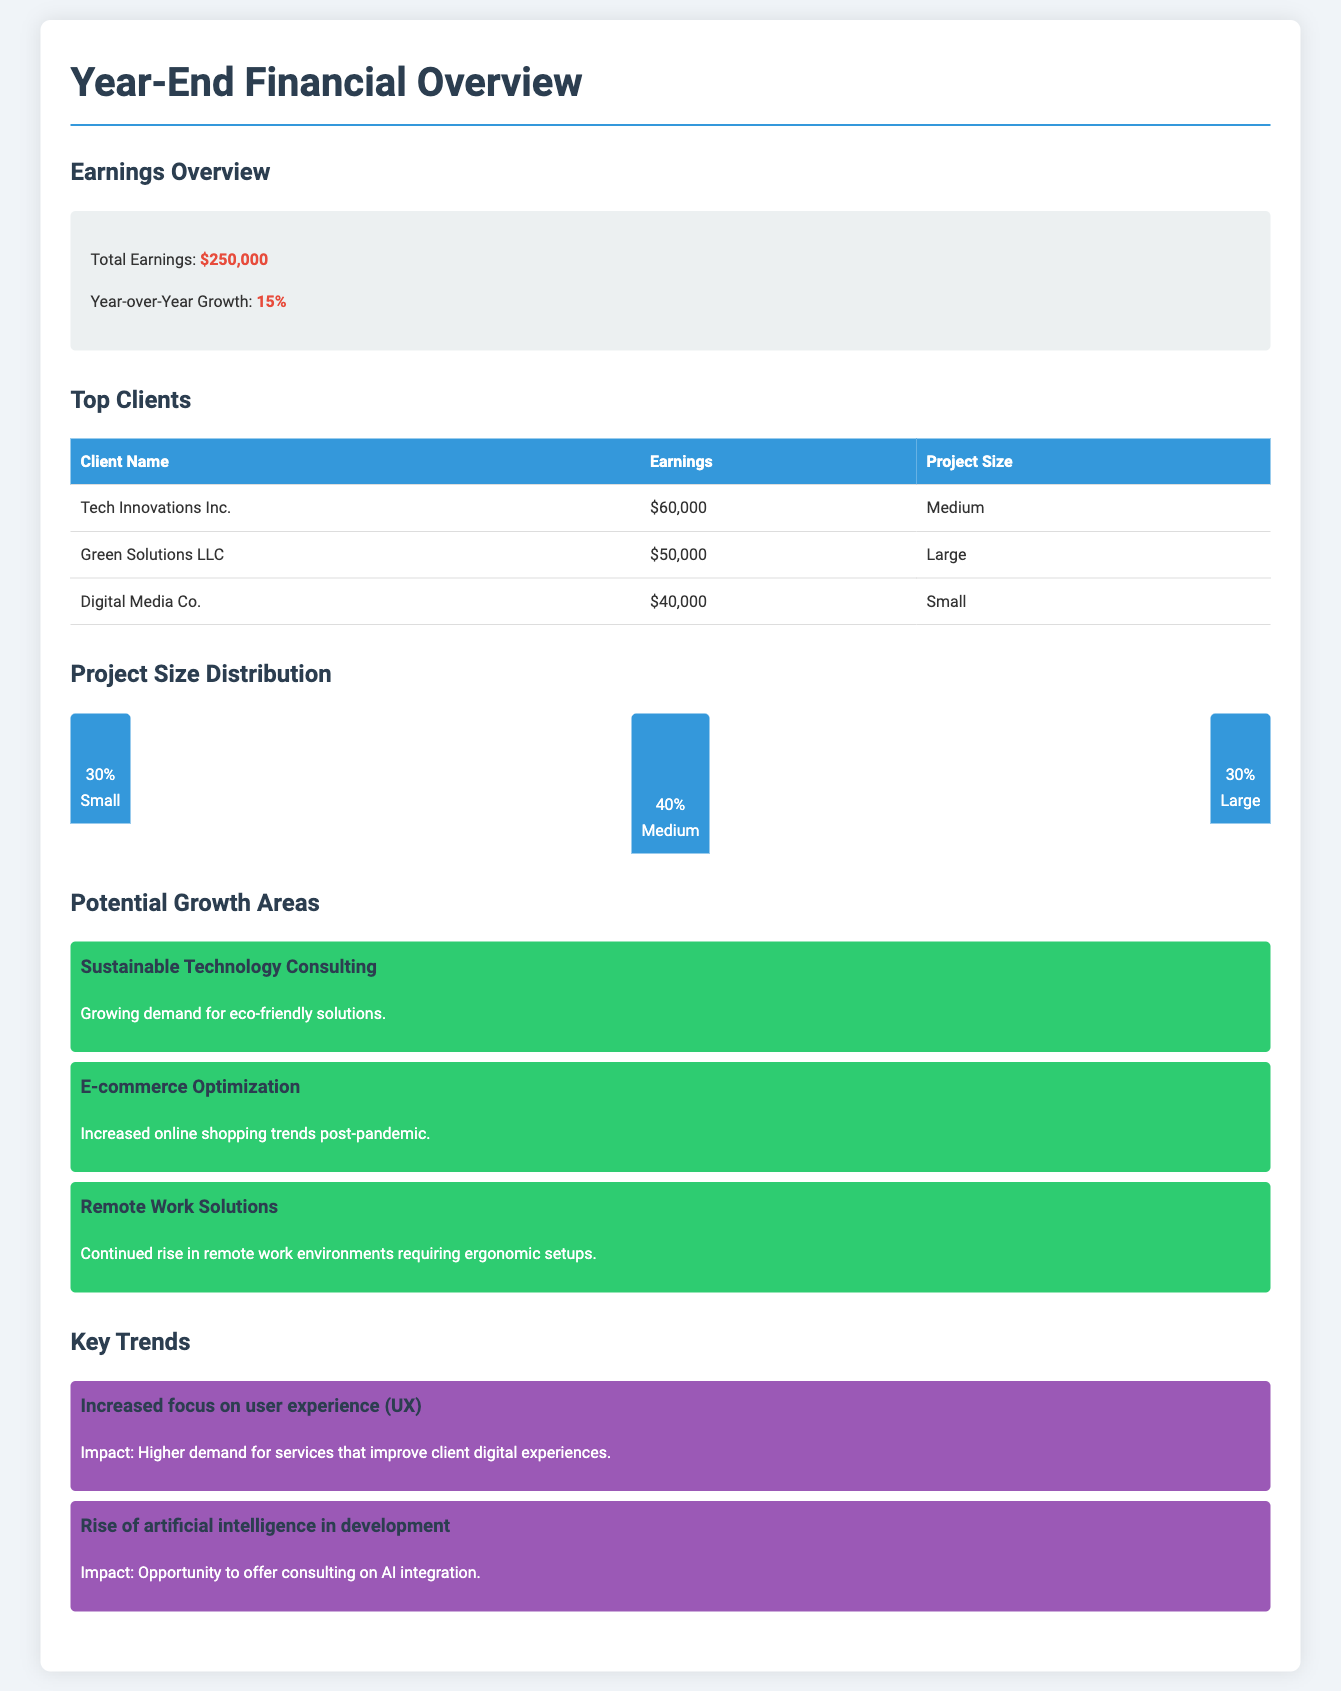What is the total earnings? The total earnings is explicitly stated in the document, which is $250,000.
Answer: $250,000 What is the year-over-year growth percentage? The year-over-year growth percentage is given in the Earnings Overview section, which is 15%.
Answer: 15% Who is the top client by earnings? The document lists clients and their earnings, with the highest being Tech Innovations Inc. at $60,000.
Answer: Tech Innovations Inc What percentage of projects are categorized as Medium? In the Project Size Distribution section, it is noted that 40% of the projects are medium-sized.
Answer: 40% What are two potential growth areas mentioned? The document highlights multiple growth areas, including Sustainable Technology Consulting and E-commerce Optimization.
Answer: Sustainable Technology Consulting, E-commerce Optimization What is the impact of increased focus on user experience (UX)? The document elaborates on key trends, stating that it leads to higher demand for services that improve client digital experiences.
Answer: Higher demand for services that improve client digital experiences How many top clients are listed in the report? The Top Clients section contains a table listing three clients.
Answer: Three What is the project size distribution for Small projects? The chart indicates that Small projects account for 30% of the total projects.
Answer: 30% 